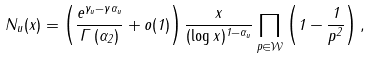Convert formula to latex. <formula><loc_0><loc_0><loc_500><loc_500>N _ { u } ( x ) = \left ( \frac { e ^ { \gamma _ { u } - \gamma \alpha _ { u } } } { \Gamma \left ( \alpha _ { 2 } \right ) } + o ( 1 ) \right ) \frac { x } { ( \log x ) ^ { 1 - \alpha _ { u } } } \prod _ { p \in \mathcal { W } } \left ( 1 - \frac { 1 } { p ^ { 2 } } \right ) ,</formula> 